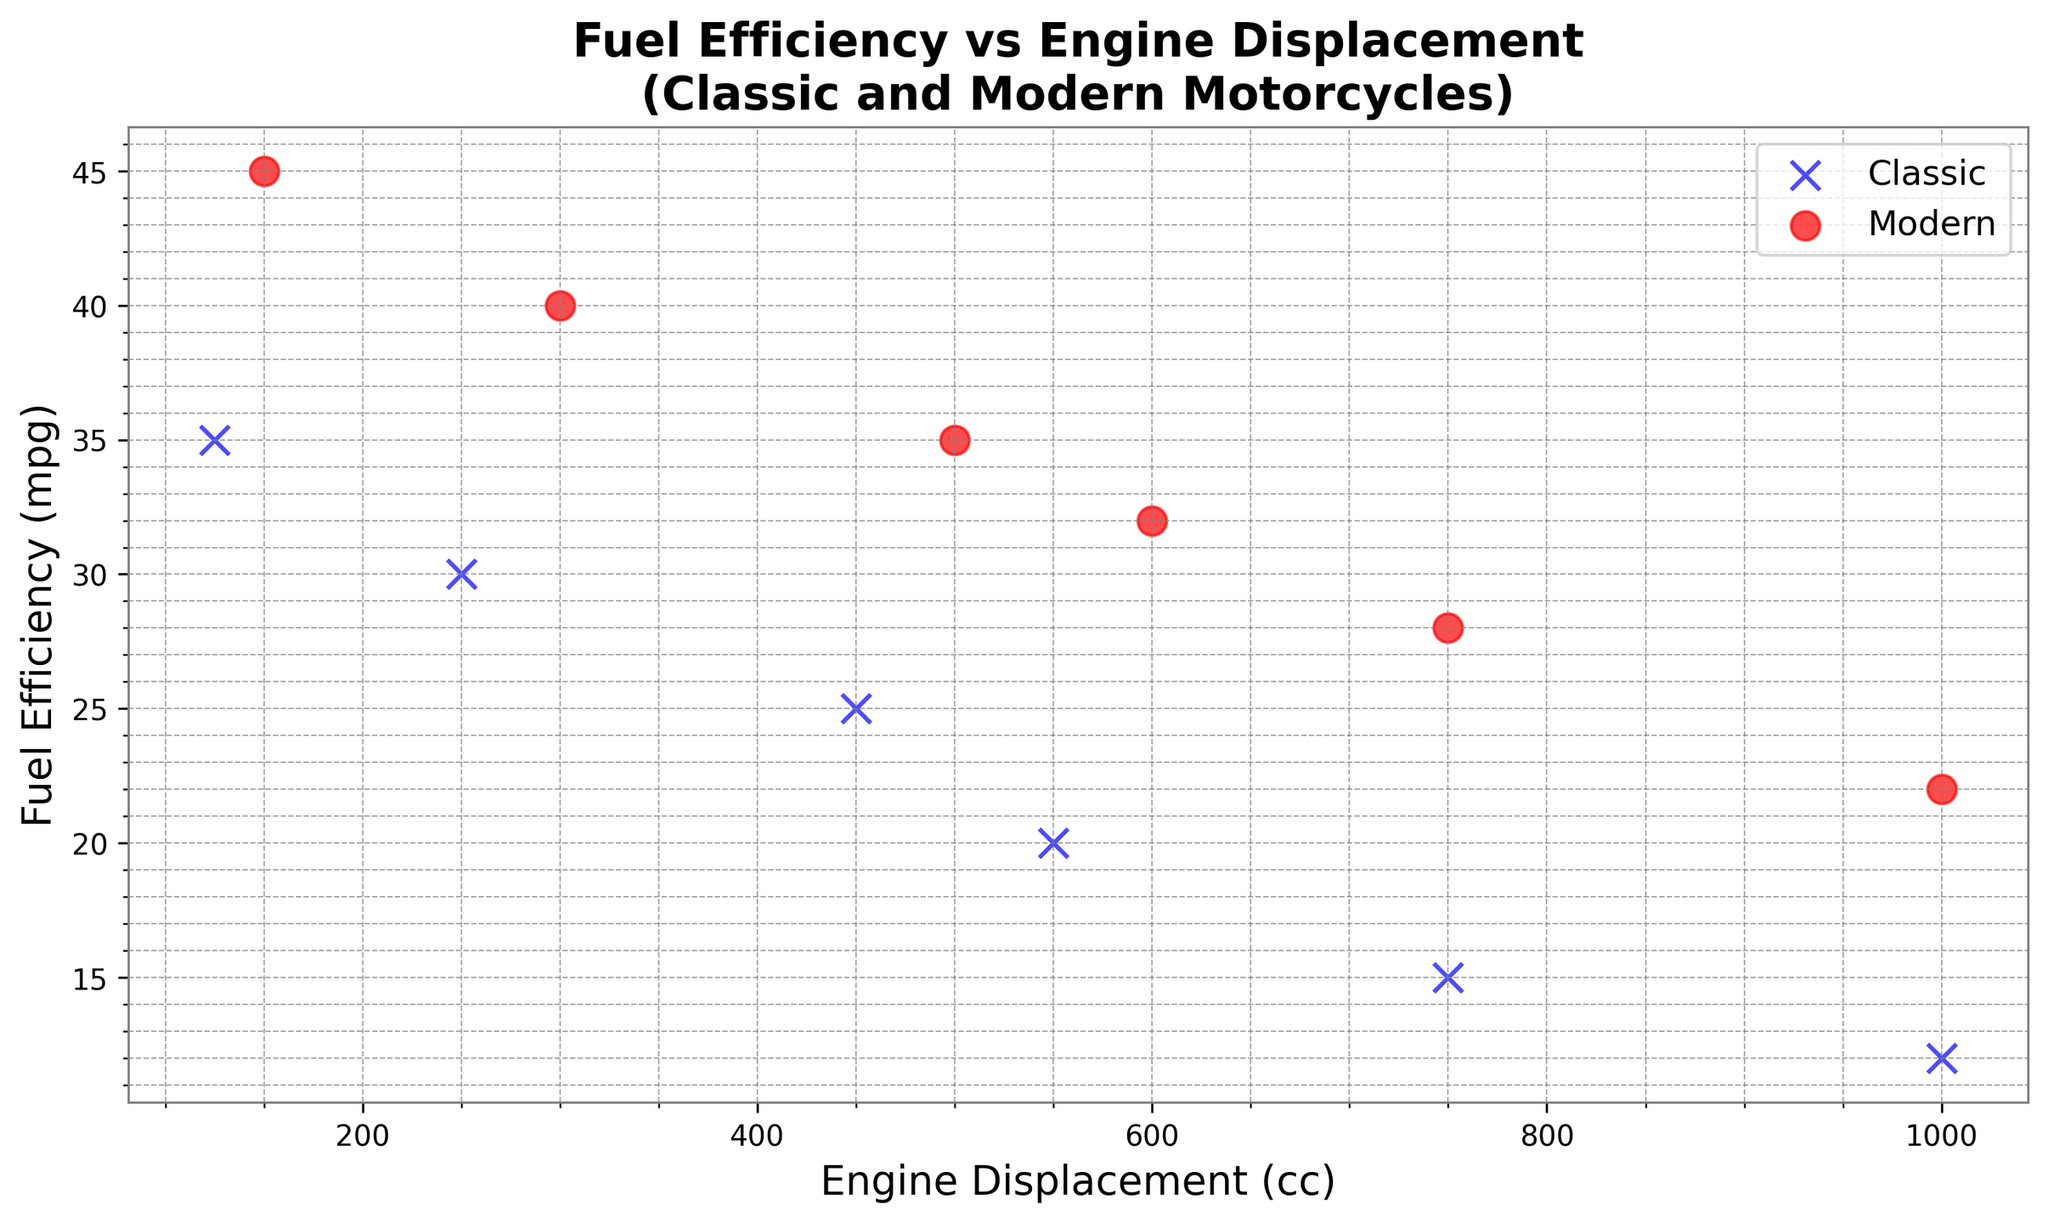What is the trend in fuel efficiency as engine displacement increases for classic motorcycles? By examining the blue 'x' markers representing classic motorcycles, we can observe a downward trend indicating that fuel efficiency generally decreases as engine displacement increases.
Answer: Fuel efficiency decreases What is the range of engine displacements for modern motorcycles? By looking at the red 'o' markers representing modern motorcycles, we see engine displacements range from 150 cc to 1000 cc.
Answer: 150 cc to 1000 cc Which type of motorcycles tends to have higher fuel efficiency for the same engine displacement? By comparing the blue 'x' markers (classic) and red 'o' markers (modern) on the plot for the same engine displacements, we see that modern motorcycles generally have higher fuel efficiency.
Answer: Modern Is there any data point where classic and modern motorcycles have the same engine displacement? If so, how does their fuel efficiency compare? Both classic and modern motorcycles share engine displacements of 750 cc and 1000 cc. For 750 cc, the fuel efficiency is 15 mpg (classic) and 28 mpg (modern). For 1000 cc, it's 12 mpg (classic) and 22 mpg (modern). Modern motorcycles have higher fuel efficiency in both cases.
Answer: Yes, modern motorcycles have higher fuel efficiency Which modern motorcycle has the highest fuel efficiency and what is its engine displacement? By looking at the red 'o' markers, the highest fuel efficiency is 45 mpg, and it corresponds to an engine displacement of 150 cc.
Answer: 45 mpg, 150 cc What is the difference in fuel efficiency between the most fuel-efficient modern motorcycle and the most fuel-efficient classic motorcycle? The most fuel-efficient modern motorcycle has 45 mpg (150 cc), while the most fuel-efficient classic motorcycle has 35 mpg (125 cc). The difference is 45 mpg - 35 mpg = 10 mpg.
Answer: 10 mpg What is the average fuel efficiency for classic motorcycles? There are six data points for classic motorcycles with fuel efficiencies of 35, 30, 25, 20, 15, and 12 mpg. The sum is 137 mpg, and the average is 137/6 ≈ 22.83 mpg.
Answer: ≈ 22.83 mpg How many motorcycles (both classic and modern) have an engine displacement greater than or equal to 500 cc? By counting the data points, there are two classic motorcycles (550 cc, 750 cc, 1000 cc) and four modern motorcycles (500 cc, 600 cc, 750 cc, 1000 cc). In total, there are six motorcycles.
Answer: 6 Are there any engine displacements where classic motorcycles have worse fuel efficiency than modern motorcycles? For engine displacements of 750 cc and 1000 cc, classic motorcycles have worse fuel efficiency (15 mpg and 12 mpg) compared to modern motorcycles (28 mpg and 22 mpg).
Answer: Yes What is the fuel efficiency of the classic motorcycle from 1974, and how does it compare to the closest modern motorcycle in terms of engine displacement? The classic motorcycle from 1974 has an engine displacement of 250 cc and a fuel efficiency of 30 mpg. The closest modern motorcycle in terms of engine displacement is 300 cc with a fuel efficiency of 40 mpg. The modern motorcycle has higher fuel efficiency.
Answer: 30 mpg; Modern is higher 